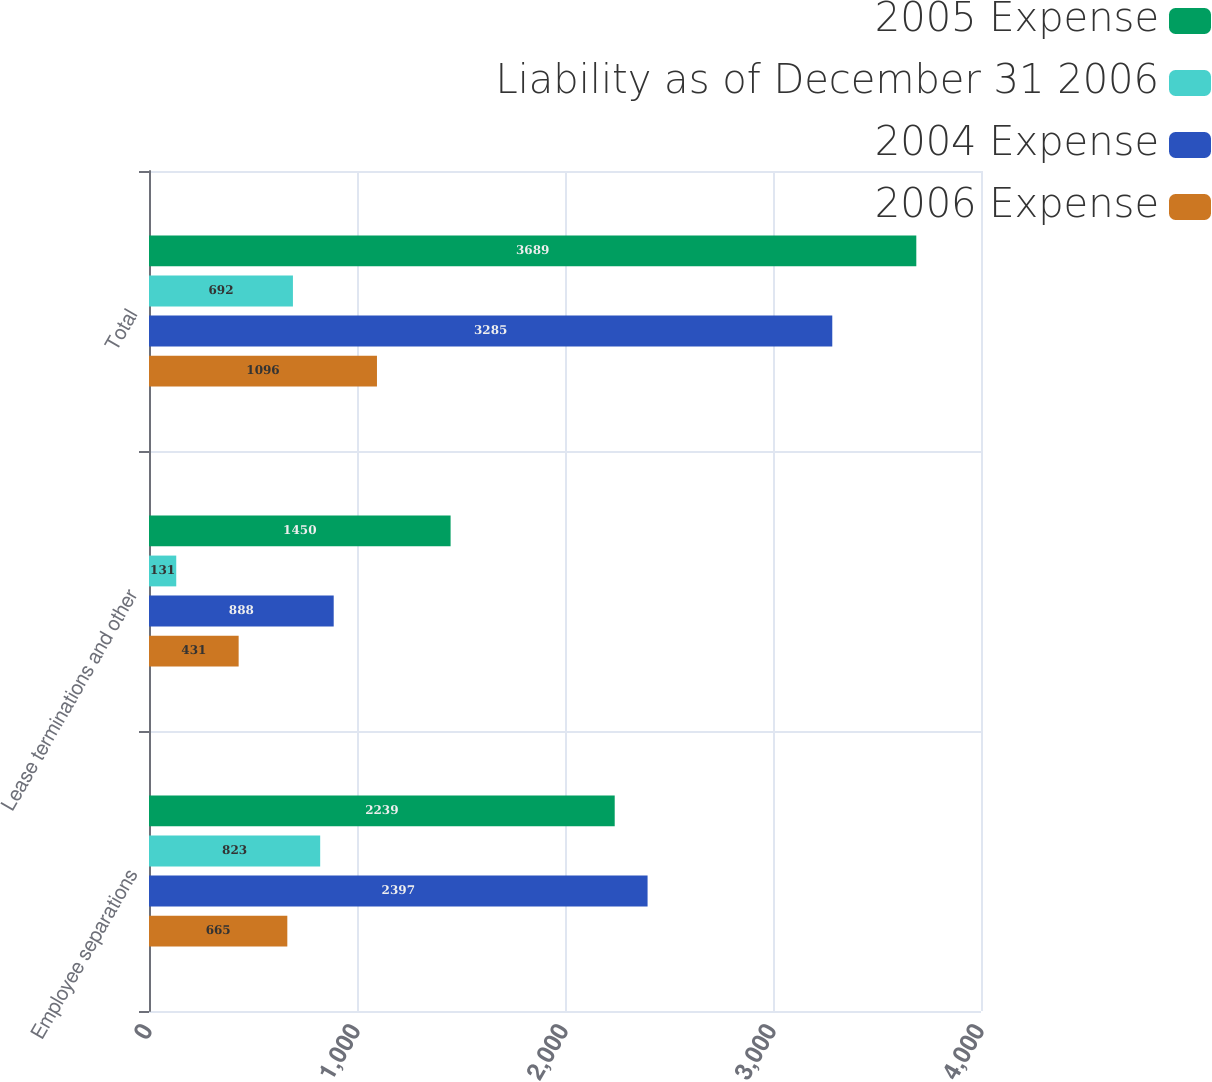Convert chart. <chart><loc_0><loc_0><loc_500><loc_500><stacked_bar_chart><ecel><fcel>Employee separations<fcel>Lease terminations and other<fcel>Total<nl><fcel>2005 Expense<fcel>2239<fcel>1450<fcel>3689<nl><fcel>Liability as of December 31 2006<fcel>823<fcel>131<fcel>692<nl><fcel>2004 Expense<fcel>2397<fcel>888<fcel>3285<nl><fcel>2006 Expense<fcel>665<fcel>431<fcel>1096<nl></chart> 